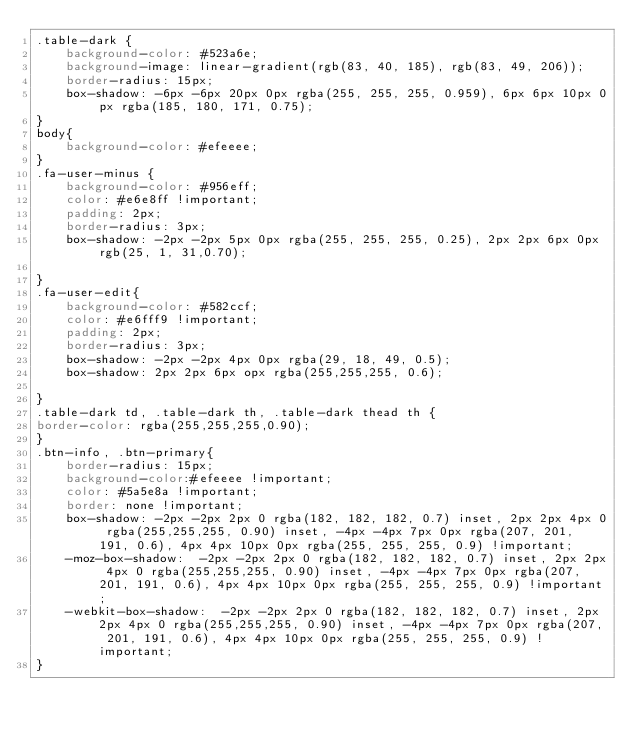<code> <loc_0><loc_0><loc_500><loc_500><_CSS_>.table-dark {
    background-color: #523a6e;
    background-image: linear-gradient(rgb(83, 40, 185), rgb(83, 49, 206));
    border-radius: 15px;
    box-shadow: -6px -6px 20px 0px rgba(255, 255, 255, 0.959), 6px 6px 10px 0px rgba(185, 180, 171, 0.75);
}
body{
    background-color: #efeeee;
}
.fa-user-minus {
    background-color: #956eff;
    color: #e6e8ff !important;
    padding: 2px;
    border-radius: 3px;
    box-shadow: -2px -2px 5px 0px rgba(255, 255, 255, 0.25), 2px 2px 6px 0px rgb(25, 1, 31,0.70);

}
.fa-user-edit{
    background-color: #582ccf;
    color: #e6fff9 !important;
    padding: 2px;
    border-radius: 3px;
    box-shadow: -2px -2px 4px 0px rgba(29, 18, 49, 0.5); 
    box-shadow: 2px 2px 6px opx rgba(255,255,255, 0.6);

}
.table-dark td, .table-dark th, .table-dark thead th {
border-color: rgba(255,255,255,0.90);
}
.btn-info, .btn-primary{
    border-radius: 15px;
    background-color:#efeeee !important;
    color: #5a5e8a !important;
    border: none !important;
    box-shadow: -2px -2px 2px 0 rgba(182, 182, 182, 0.7) inset, 2px 2px 4px 0 rgba(255,255,255, 0.90) inset, -4px -4px 7px 0px rgba(207, 201, 191, 0.6), 4px 4px 10px 0px rgba(255, 255, 255, 0.9) !important;
    -moz-box-shadow:  -2px -2px 2px 0 rgba(182, 182, 182, 0.7) inset, 2px 2px 4px 0 rgba(255,255,255, 0.90) inset, -4px -4px 7px 0px rgba(207, 201, 191, 0.6), 4px 4px 10px 0px rgba(255, 255, 255, 0.9) !important;
    -webkit-box-shadow:  -2px -2px 2px 0 rgba(182, 182, 182, 0.7) inset, 2px 2px 4px 0 rgba(255,255,255, 0.90) inset, -4px -4px 7px 0px rgba(207, 201, 191, 0.6), 4px 4px 10px 0px rgba(255, 255, 255, 0.9) !important;
}</code> 